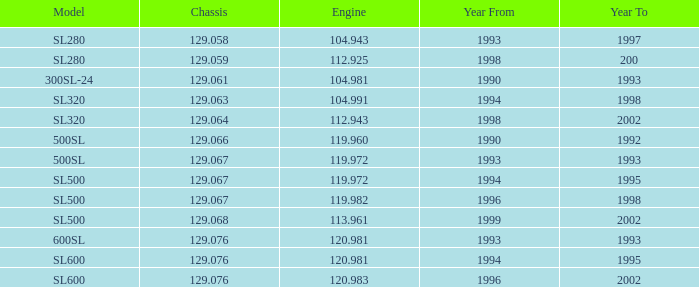Which Year To has an Engine of 119.972, and a Chassis smaller than 129.067? None. 